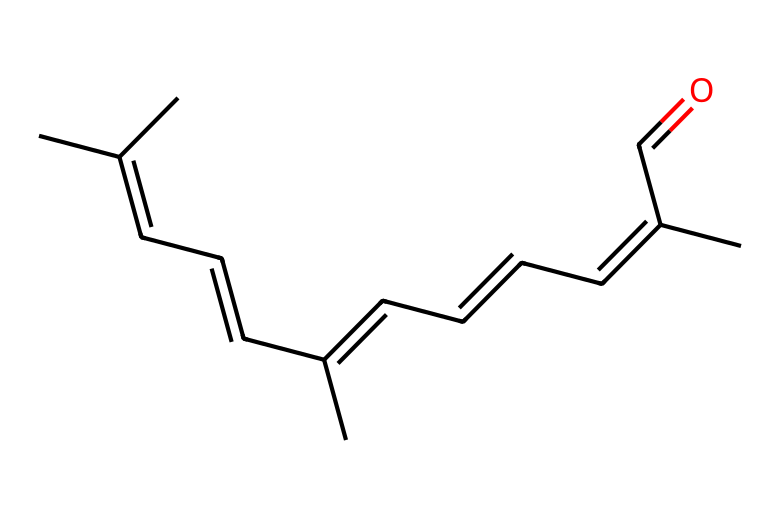What is the molecular formula of retinal? Count the number of carbon (C), hydrogen (H), and oxygen (O) atoms in the structure represented by the SMILES. There are 20 carbon atoms, 28 hydrogen atoms, and 1 oxygen atom, leading to the formula C20H28O.
Answer: C20H28O How many double bonds are present in retinal? By examining the structure and the SMILES representation, we can identify that there are 5 double bonds in the chain of retinal due to the alternating single and double bonds in the carbon backbone.
Answer: 5 Is retinal a geometric isomer? Retinal has multiple double bonds with cis and trans arrangements, therefore it exists in forms that are structurally the same but differ in the spatial arrangement of groups around these double bonds, qualifying it as a geometric isomer.
Answer: Yes What is the E-Z configuration of retinal? The longest carbon chains attached to the double bonds of retinal show that the higher priority groups are on opposite sides of the double bond, indicating it has an E configuration for at least one of its double bonds.
Answer: E How does retinal contribute to vision? Retinal plays a critical role in the visual cycle by changing shape upon light absorption to initiate a biochemical cascade that signals transduction in the photoreceptors of the retina.
Answer: Light signal Why is the E-Z configuration important in a molecule like retinal? The E-Z configuration affects how retinal interacts with proteins in the eye, particularly affecting its ability to undergo conformational changes that are essential for vision and phototransduction cascade.
Answer: Interaction 